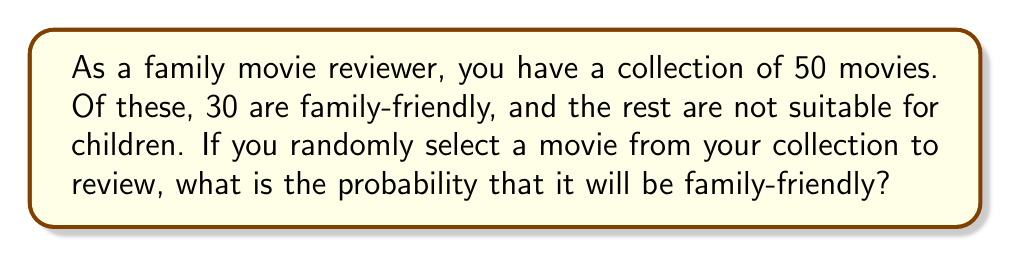Give your solution to this math problem. To solve this problem, we'll use the basic probability formula:

$$P(\text{event}) = \frac{\text{number of favorable outcomes}}{\text{total number of possible outcomes}}$$

In this case:
1. The total number of movies (possible outcomes) is 50.
2. The number of family-friendly movies (favorable outcomes) is 30.

Let's substitute these values into our formula:

$$P(\text{family-friendly}) = \frac{30}{50}$$

To simplify this fraction:
1. Divide both the numerator and denominator by their greatest common divisor (10):

$$P(\text{family-friendly}) = \frac{30 \div 10}{50 \div 10} = \frac{3}{5}$$

Therefore, the probability of selecting a family-friendly movie is $\frac{3}{5}$ or 0.6 or 60%.
Answer: $\frac{3}{5}$ 